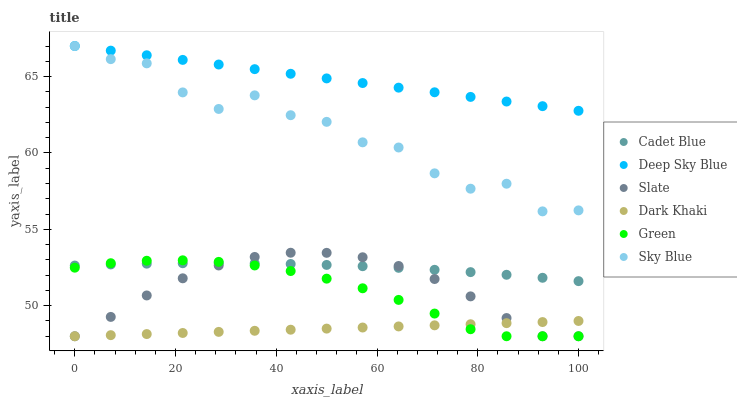Does Dark Khaki have the minimum area under the curve?
Answer yes or no. Yes. Does Deep Sky Blue have the maximum area under the curve?
Answer yes or no. Yes. Does Slate have the minimum area under the curve?
Answer yes or no. No. Does Slate have the maximum area under the curve?
Answer yes or no. No. Is Deep Sky Blue the smoothest?
Answer yes or no. Yes. Is Sky Blue the roughest?
Answer yes or no. Yes. Is Slate the smoothest?
Answer yes or no. No. Is Slate the roughest?
Answer yes or no. No. Does Slate have the lowest value?
Answer yes or no. Yes. Does Deep Sky Blue have the lowest value?
Answer yes or no. No. Does Sky Blue have the highest value?
Answer yes or no. Yes. Does Slate have the highest value?
Answer yes or no. No. Is Slate less than Deep Sky Blue?
Answer yes or no. Yes. Is Deep Sky Blue greater than Slate?
Answer yes or no. Yes. Does Dark Khaki intersect Slate?
Answer yes or no. Yes. Is Dark Khaki less than Slate?
Answer yes or no. No. Is Dark Khaki greater than Slate?
Answer yes or no. No. Does Slate intersect Deep Sky Blue?
Answer yes or no. No. 